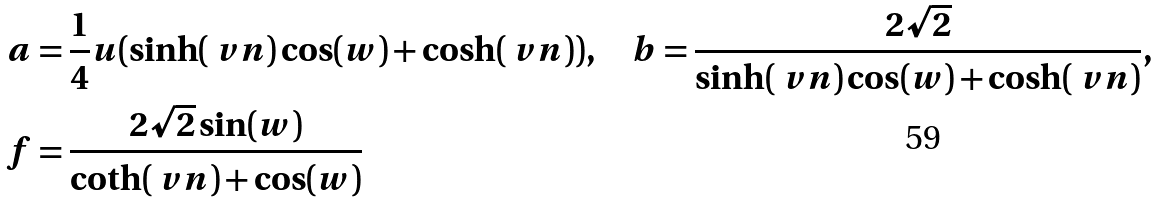Convert formula to latex. <formula><loc_0><loc_0><loc_500><loc_500>a & = \frac { 1 } { 4 } u ( \sinh ( \ v n ) \cos ( w ) + \cosh ( \ v n ) ) , \quad b = \frac { 2 \sqrt { 2 } } { \sinh ( \ v n ) \cos ( w ) + \cosh ( \ v n ) } , \\ f & = \frac { 2 \sqrt { 2 } \sin ( w ) } { \coth ( \ v n ) + \cos ( w ) }</formula> 